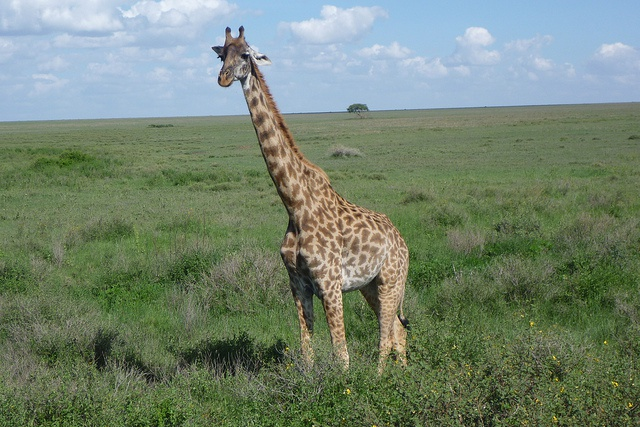Describe the objects in this image and their specific colors. I can see a giraffe in lightblue, gray, and tan tones in this image. 